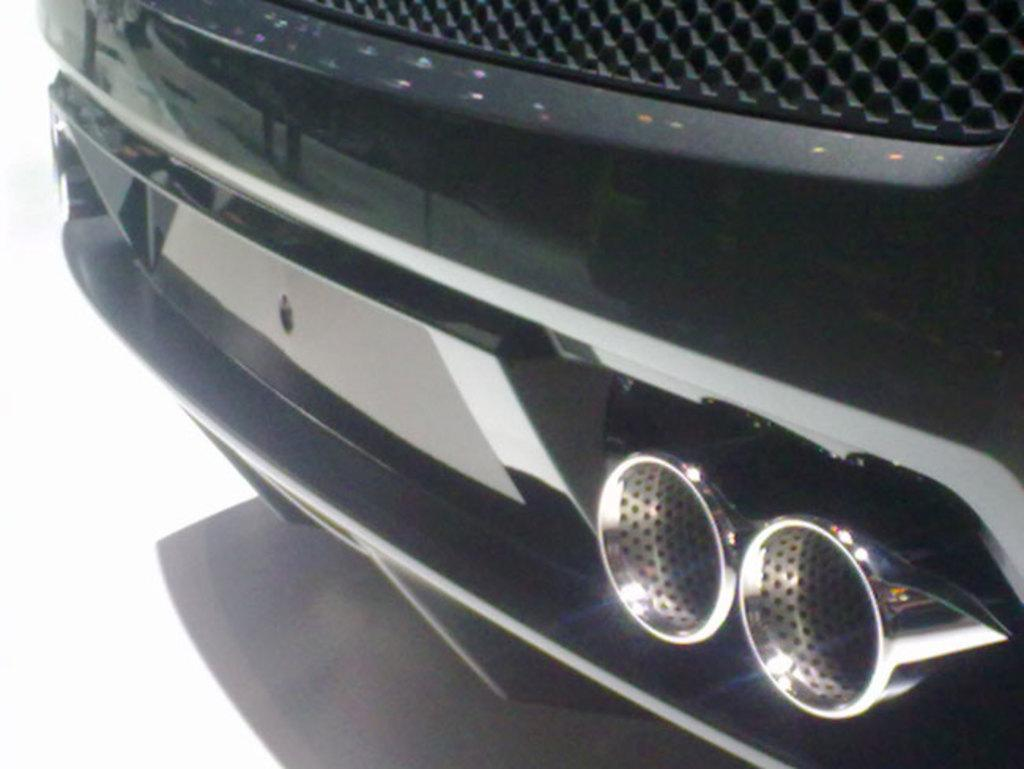What type of object is partially visible in the image? There is a part of a vehicle in the image. Can you describe the shape of the objects attached to the vehicle? There are two cylinder-shaped objects (car silencers) in the image. What color is the background of the image? The background of the image is white. What type of journey is the man planning to take with the map in the image? There is no man or map present in the image; it only features a part of a vehicle and two car silencers. 